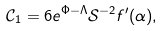<formula> <loc_0><loc_0><loc_500><loc_500>\mathcal { C } _ { 1 } = 6 e ^ { \Phi - \Lambda } \mathcal { S } ^ { - 2 } f ^ { \prime } ( \alpha ) ,</formula> 